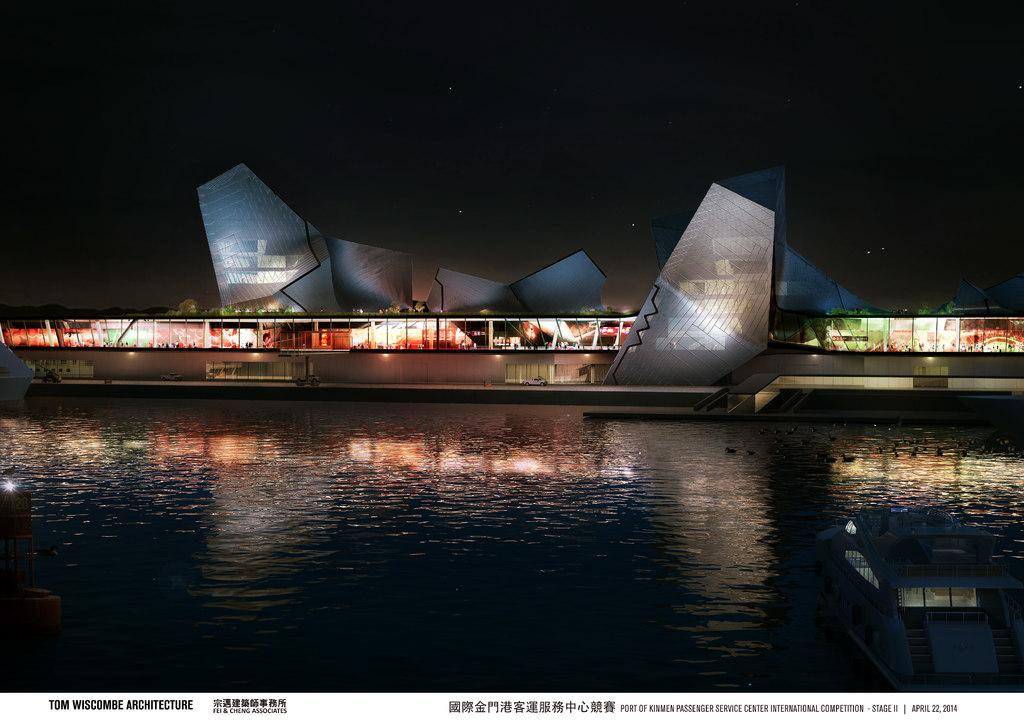What is at the bottom of the image? There is water at the bottom of the image. What can be seen in the middle of the image? There is a ship with lights in the middle of the image. What is visible at the top of the image? The sky is visible at the top of the image. What type of shade is covering the ship in the image? There is no shade covering the ship in the image; it is visible in the water with lights on. 